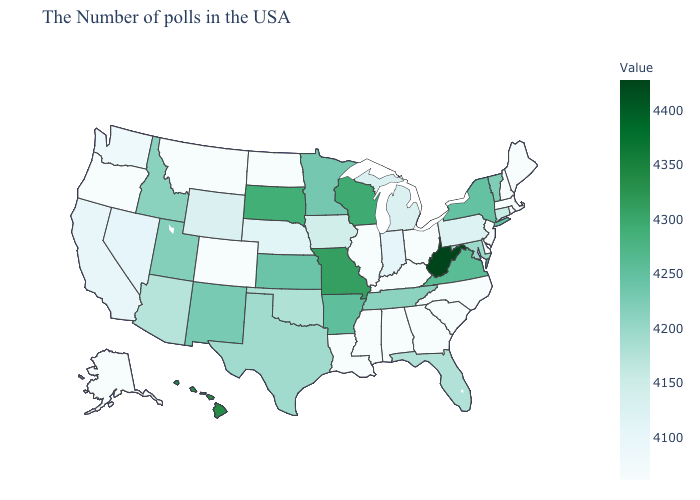Does the map have missing data?
Short answer required. No. Which states hav the highest value in the Northeast?
Write a very short answer. New York. Which states have the lowest value in the MidWest?
Write a very short answer. Ohio, Illinois, North Dakota. Does Missouri have the highest value in the MidWest?
Short answer required. Yes. Does Maryland have the highest value in the USA?
Short answer required. No. Does North Dakota have the lowest value in the MidWest?
Write a very short answer. Yes. 